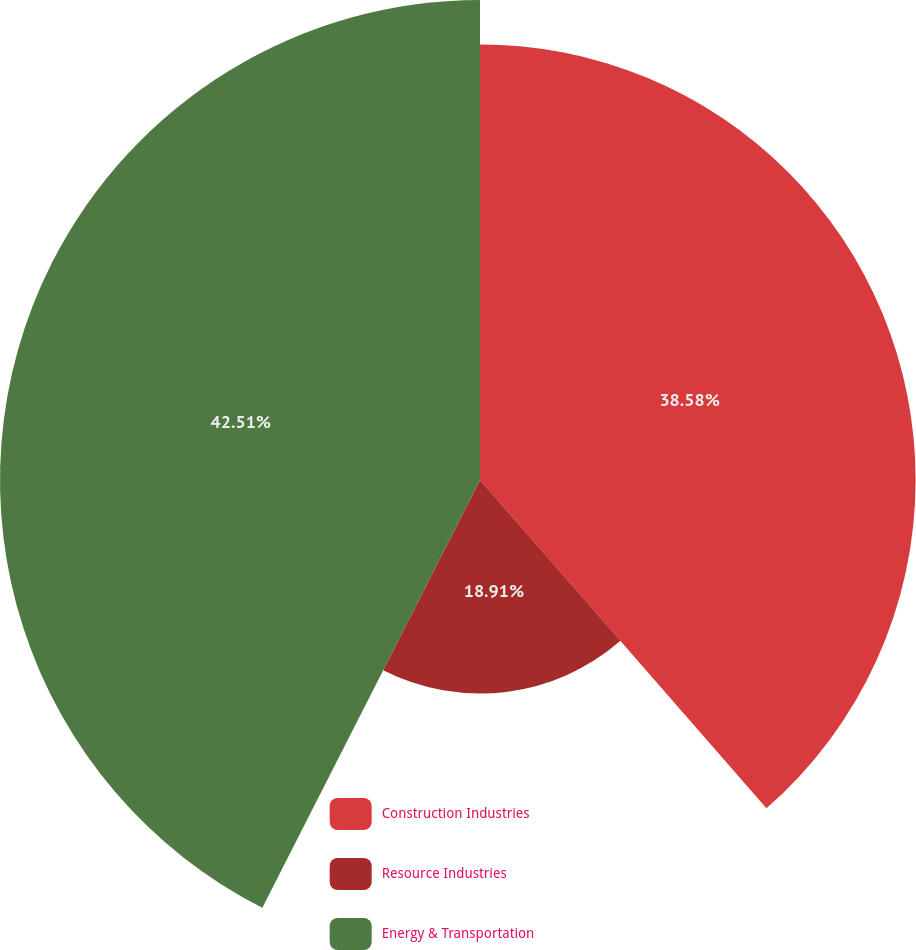Convert chart to OTSL. <chart><loc_0><loc_0><loc_500><loc_500><pie_chart><fcel>Construction Industries<fcel>Resource Industries<fcel>Energy & Transportation<nl><fcel>38.58%<fcel>18.91%<fcel>42.51%<nl></chart> 